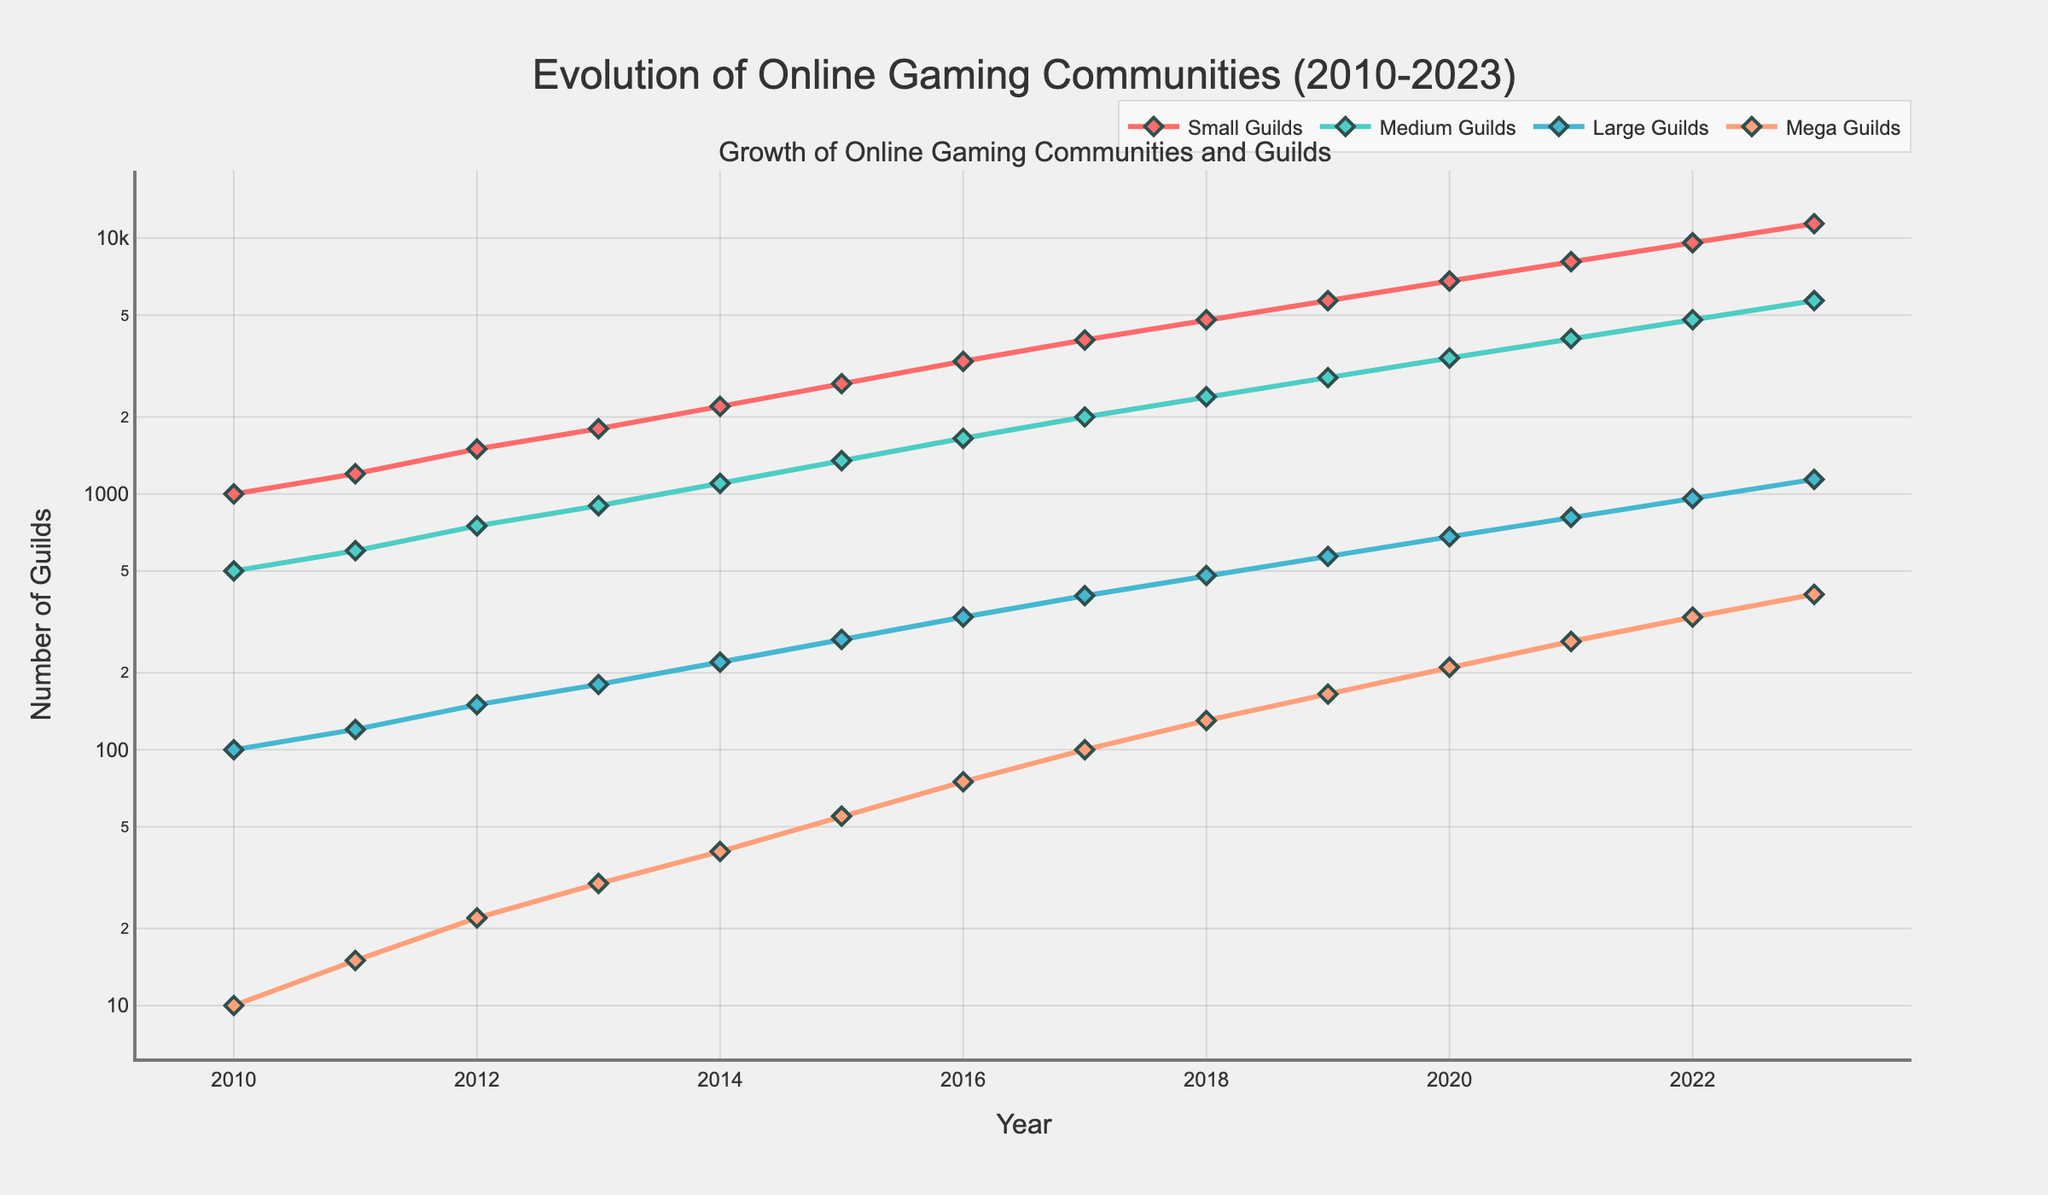What trend is observed for the number of Small Guilds between 2015 and 2018? The plot shows a steady and consistent increase in the number of Small Guilds each year between 2015 and 2018. The number rises from 2700 in 2015 to 4800 in 2018.
Answer: Steady increase Which type of guild showed the highest growth rate from 2010 to 2023? By comparing the slopes of the four lines, the line for Mega Guilds has the steepest slope, indicating the highest growth rate among the four guild types, increasing from 10 to 405.
Answer: Mega Guilds What is the approximate total number of Small and Medium Guilds in 2020? From the plot, Small Guilds are around 6800 and Medium Guilds are around 3400 in 2020. Adding these together gives 10200.
Answer: 10200 How does the number of Large Guilds in 2014 compare to the number of Mega Guilds in 2021? In the plot, the number of Large Guilds in 2014 is approximately 220 while the number of Mega Guilds in 2021 is about 265. Hence, Mega Guilds in 2021 are greater.
Answer: Mega Guilds > Large Guilds Are there any guild categories that do not show a consistent increase over the years? The plot shows that all four guild categories (Small, Medium, Large, Mega) demonstrate a consistent increase in their numbers over the years from 2010 to 2023.
Answer: No What is the average number of Large Guilds between 2010 and 2015? The numbers for Large Guilds from 2010 to 2015 are 100, 120, 150, 180, 220, and 270. Adding these values gives 1040, and dividing by 6 gives an average of approximately 173.33.
Answer: 173.33 Which guild category had the smallest increase in numbers from 2010 to 2023? From the plot, Small Guilds grew from 1000 to 11400, Medium Guilds from 500 to 5700, Large Guilds from 100 to 1140, and Mega Guilds from 10 to 405. The smallest increase is observed in Mega Guilds.
Answer: Mega Guilds What year did Medium Guilds surpass 1000 in number? The plot shows that Medium Guilds surpassed 1000 in number in 2014, rising from 900 in 2013 to 1100 in 2014.
Answer: 2014 What is the difference in the number of Small Guilds between 2021 and 2023? In the plot, Small Guilds number 8100 in 2021 and 11400 in 2023. The difference is calculated as 11400 - 8100 = 3300.
Answer: 3300 